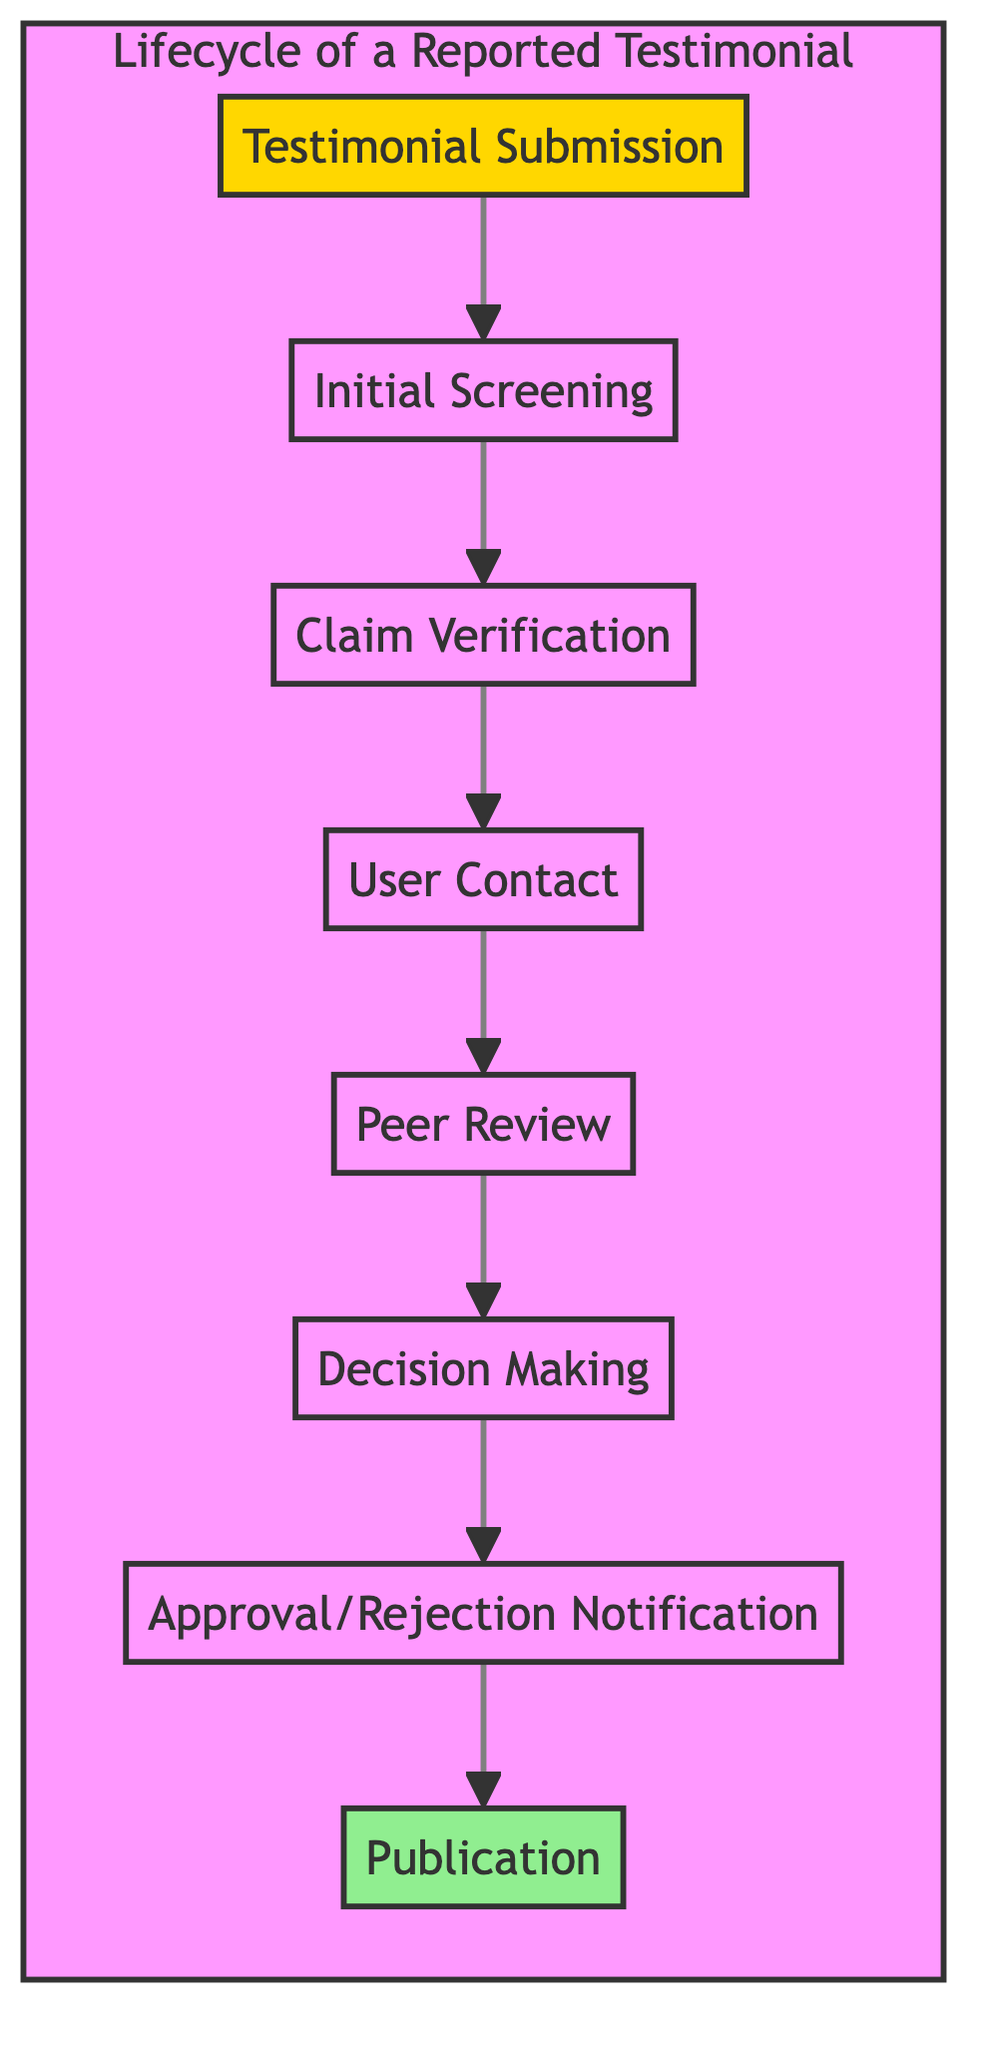What is the first step in the lifecycle? The first step in the lifecycle is indicated at the bottom of the flow chart, where the arrow points upwards; it shows "Testimonial Submission".
Answer: Testimonial Submission How many steps are there in total? By counting the nodes in the flowchart, there are eight distinct steps listed from submission to publication.
Answer: 8 What step follows "Claim Verification"? Looking at the flow of the diagram, "Claim Verification" is directly connected to "User Contact" as the next step in the flow.
Answer: User Contact Which step represents the submission of a testimonial? The flowchart starts with "Testimonial Submission" as the foundational step of the process depicted at the lower end of the chart.
Answer: Testimonial Submission What is the last step in the lifecycle? The last step is shown at the top of the flowchart, which indicates that published testimonials are made visible to all users; hence it is "Publication".
Answer: Publication What is the relationship between "Peer Review" and "Decision Making"? In the flowchart, "Peer Review" feeds directly into "Decision Making," meaning that the output from peer reviews influences the decision-making process.
Answer: Peer Review feeds into Decision Making During which step does the moderator contact the user? The diagram shows that the specific point at which the moderator may contact the user occurs directly after "Claim Verification" and is denoted as "User Contact".
Answer: User Contact How does a testimonial get approved? The flowchart illustrates that a testimonial gets approved after the moderator makes a decision based on data collected from previous steps, culminating in "Approval/Rejection Notification".
Answer: Decision Making What indicates the final outcome of a testimonial review? The very last node at the top of the diagram signifies the conclusion of the testimonial process, represented as "Publication."
Answer: Publication 